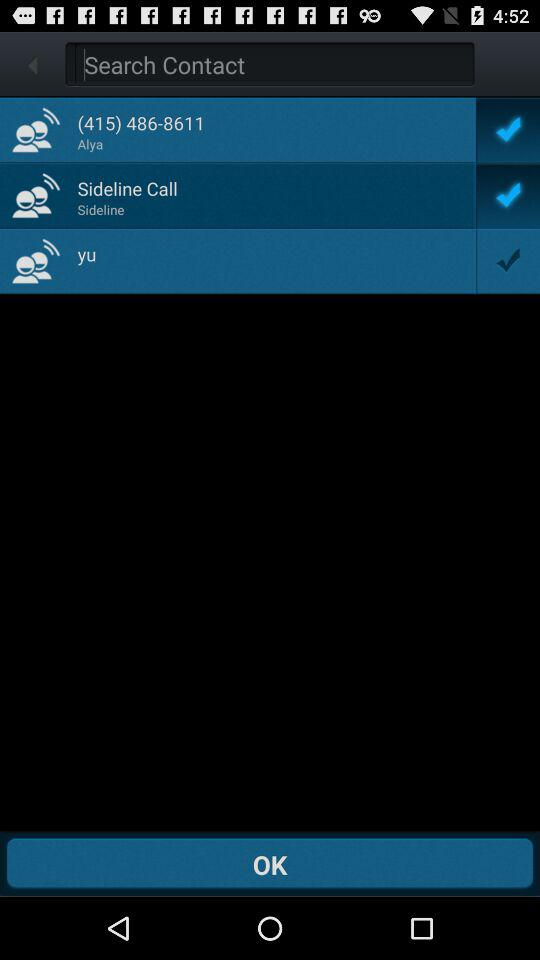What is the contact number of Alya? Alya's contact number is (415) 486-8611. 